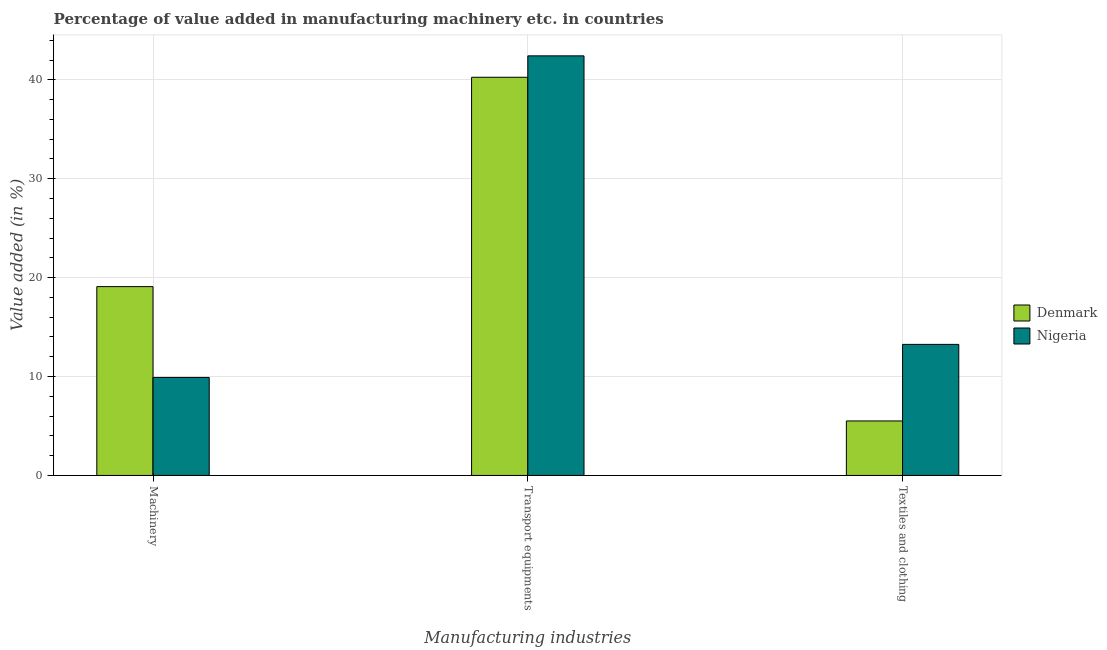How many different coloured bars are there?
Offer a terse response. 2. What is the label of the 3rd group of bars from the left?
Your answer should be very brief. Textiles and clothing. What is the value added in manufacturing machinery in Nigeria?
Keep it short and to the point. 9.91. Across all countries, what is the maximum value added in manufacturing machinery?
Provide a succinct answer. 19.09. Across all countries, what is the minimum value added in manufacturing textile and clothing?
Provide a short and direct response. 5.51. In which country was the value added in manufacturing textile and clothing maximum?
Give a very brief answer. Nigeria. In which country was the value added in manufacturing machinery minimum?
Provide a short and direct response. Nigeria. What is the total value added in manufacturing transport equipments in the graph?
Provide a short and direct response. 82.7. What is the difference between the value added in manufacturing textile and clothing in Nigeria and that in Denmark?
Make the answer very short. 7.74. What is the difference between the value added in manufacturing machinery in Denmark and the value added in manufacturing transport equipments in Nigeria?
Offer a very short reply. -23.34. What is the average value added in manufacturing textile and clothing per country?
Offer a very short reply. 9.38. What is the difference between the value added in manufacturing machinery and value added in manufacturing textile and clothing in Nigeria?
Your answer should be compact. -3.34. What is the ratio of the value added in manufacturing transport equipments in Denmark to that in Nigeria?
Ensure brevity in your answer.  0.95. What is the difference between the highest and the second highest value added in manufacturing textile and clothing?
Make the answer very short. 7.74. What is the difference between the highest and the lowest value added in manufacturing machinery?
Ensure brevity in your answer.  9.18. What does the 2nd bar from the left in Machinery represents?
Provide a succinct answer. Nigeria. What does the 1st bar from the right in Transport equipments represents?
Give a very brief answer. Nigeria. How many bars are there?
Make the answer very short. 6. Are all the bars in the graph horizontal?
Offer a very short reply. No. How are the legend labels stacked?
Offer a terse response. Vertical. What is the title of the graph?
Your answer should be very brief. Percentage of value added in manufacturing machinery etc. in countries. Does "Lebanon" appear as one of the legend labels in the graph?
Provide a succinct answer. No. What is the label or title of the X-axis?
Keep it short and to the point. Manufacturing industries. What is the label or title of the Y-axis?
Provide a succinct answer. Value added (in %). What is the Value added (in %) of Denmark in Machinery?
Make the answer very short. 19.09. What is the Value added (in %) in Nigeria in Machinery?
Offer a very short reply. 9.91. What is the Value added (in %) of Denmark in Transport equipments?
Provide a short and direct response. 40.27. What is the Value added (in %) of Nigeria in Transport equipments?
Your answer should be compact. 42.43. What is the Value added (in %) in Denmark in Textiles and clothing?
Provide a succinct answer. 5.51. What is the Value added (in %) of Nigeria in Textiles and clothing?
Provide a short and direct response. 13.25. Across all Manufacturing industries, what is the maximum Value added (in %) of Denmark?
Provide a succinct answer. 40.27. Across all Manufacturing industries, what is the maximum Value added (in %) of Nigeria?
Give a very brief answer. 42.43. Across all Manufacturing industries, what is the minimum Value added (in %) of Denmark?
Give a very brief answer. 5.51. Across all Manufacturing industries, what is the minimum Value added (in %) in Nigeria?
Ensure brevity in your answer.  9.91. What is the total Value added (in %) in Denmark in the graph?
Keep it short and to the point. 64.87. What is the total Value added (in %) of Nigeria in the graph?
Your answer should be very brief. 65.59. What is the difference between the Value added (in %) in Denmark in Machinery and that in Transport equipments?
Ensure brevity in your answer.  -21.17. What is the difference between the Value added (in %) of Nigeria in Machinery and that in Transport equipments?
Your answer should be compact. -32.52. What is the difference between the Value added (in %) in Denmark in Machinery and that in Textiles and clothing?
Keep it short and to the point. 13.58. What is the difference between the Value added (in %) in Nigeria in Machinery and that in Textiles and clothing?
Give a very brief answer. -3.34. What is the difference between the Value added (in %) in Denmark in Transport equipments and that in Textiles and clothing?
Keep it short and to the point. 34.75. What is the difference between the Value added (in %) in Nigeria in Transport equipments and that in Textiles and clothing?
Offer a terse response. 29.18. What is the difference between the Value added (in %) of Denmark in Machinery and the Value added (in %) of Nigeria in Transport equipments?
Make the answer very short. -23.34. What is the difference between the Value added (in %) of Denmark in Machinery and the Value added (in %) of Nigeria in Textiles and clothing?
Ensure brevity in your answer.  5.84. What is the difference between the Value added (in %) in Denmark in Transport equipments and the Value added (in %) in Nigeria in Textiles and clothing?
Offer a very short reply. 27.01. What is the average Value added (in %) of Denmark per Manufacturing industries?
Offer a terse response. 21.62. What is the average Value added (in %) of Nigeria per Manufacturing industries?
Your answer should be compact. 21.86. What is the difference between the Value added (in %) in Denmark and Value added (in %) in Nigeria in Machinery?
Your answer should be very brief. 9.18. What is the difference between the Value added (in %) in Denmark and Value added (in %) in Nigeria in Transport equipments?
Your response must be concise. -2.16. What is the difference between the Value added (in %) in Denmark and Value added (in %) in Nigeria in Textiles and clothing?
Give a very brief answer. -7.74. What is the ratio of the Value added (in %) in Denmark in Machinery to that in Transport equipments?
Give a very brief answer. 0.47. What is the ratio of the Value added (in %) in Nigeria in Machinery to that in Transport equipments?
Your answer should be very brief. 0.23. What is the ratio of the Value added (in %) in Denmark in Machinery to that in Textiles and clothing?
Make the answer very short. 3.46. What is the ratio of the Value added (in %) of Nigeria in Machinery to that in Textiles and clothing?
Your response must be concise. 0.75. What is the ratio of the Value added (in %) of Denmark in Transport equipments to that in Textiles and clothing?
Keep it short and to the point. 7.31. What is the ratio of the Value added (in %) in Nigeria in Transport equipments to that in Textiles and clothing?
Provide a succinct answer. 3.2. What is the difference between the highest and the second highest Value added (in %) of Denmark?
Make the answer very short. 21.17. What is the difference between the highest and the second highest Value added (in %) in Nigeria?
Your response must be concise. 29.18. What is the difference between the highest and the lowest Value added (in %) in Denmark?
Provide a succinct answer. 34.75. What is the difference between the highest and the lowest Value added (in %) of Nigeria?
Ensure brevity in your answer.  32.52. 